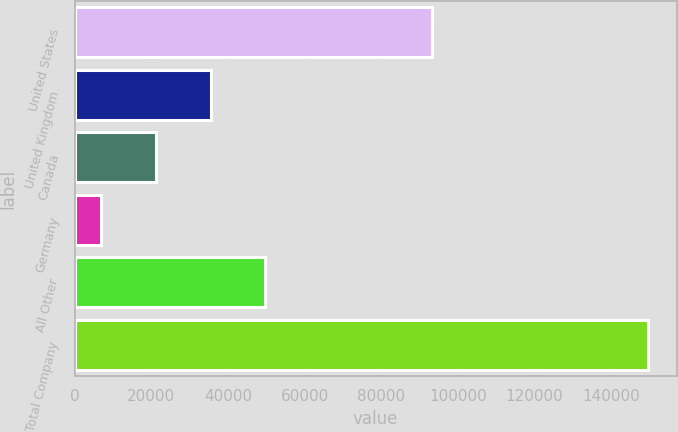Convert chart to OTSL. <chart><loc_0><loc_0><loc_500><loc_500><bar_chart><fcel>United States<fcel>United Kingdom<fcel>Canada<fcel>Germany<fcel>All Other<fcel>Total Company<nl><fcel>93142<fcel>35471.6<fcel>21210.8<fcel>6950<fcel>49732.4<fcel>149558<nl></chart> 